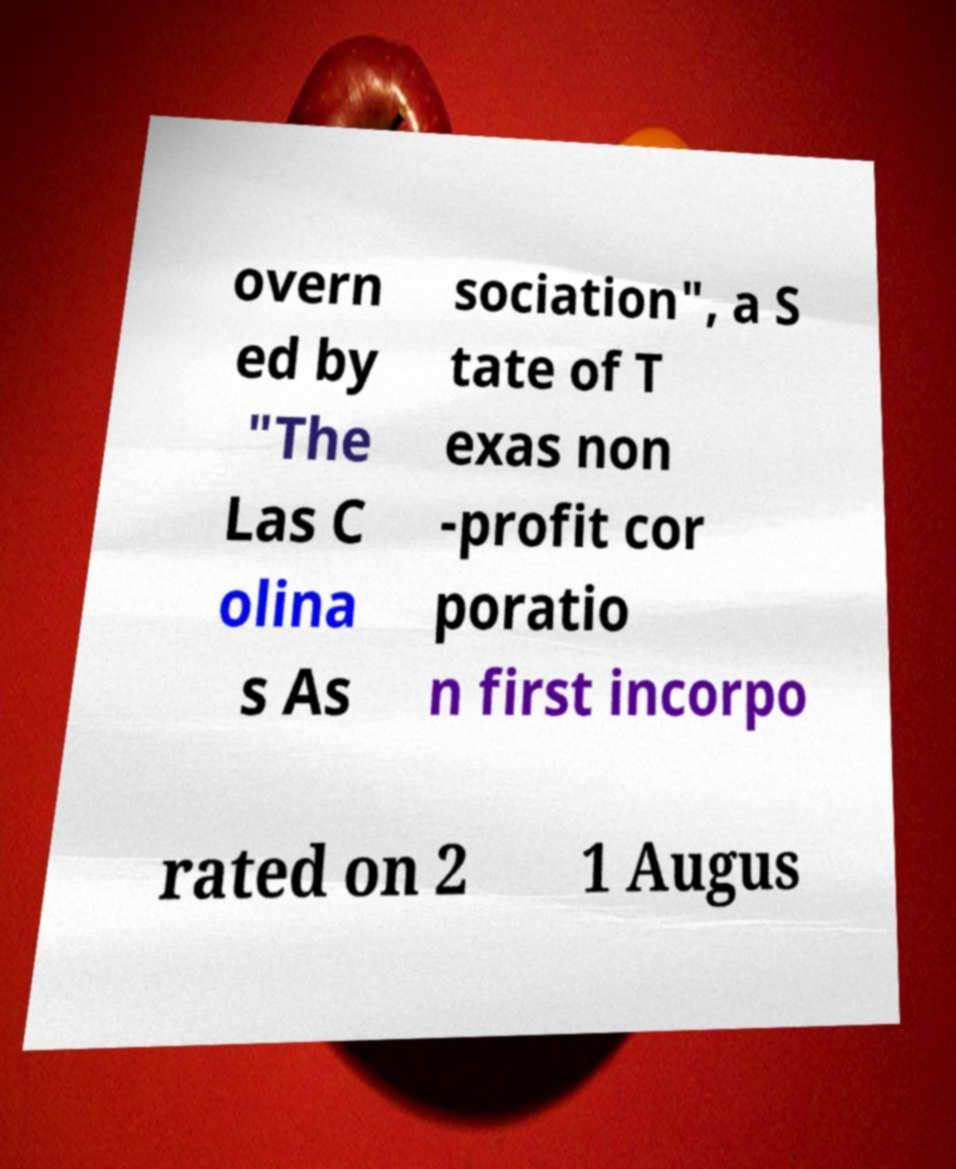Please identify and transcribe the text found in this image. overn ed by "The Las C olina s As sociation", a S tate of T exas non -profit cor poratio n first incorpo rated on 2 1 Augus 